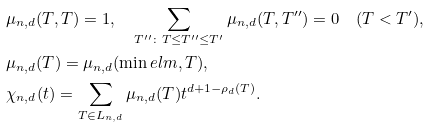Convert formula to latex. <formula><loc_0><loc_0><loc_500><loc_500>& \mu _ { n , d } ( T , T ) = 1 , \quad \sum _ { T ^ { \prime \prime } \colon T \leq T ^ { \prime \prime } \leq T ^ { \prime } } \mu _ { n , d } ( T , T ^ { \prime \prime } ) = 0 \quad ( T < T ^ { \prime } ) , \\ & \mu _ { n , d } ( T ) = \mu _ { n , d } ( \min e l m , T ) , \\ & \chi _ { n , d } ( t ) = \sum _ { T \in L _ { n , d } } \mu _ { n , d } ( T ) t ^ { d + 1 - \rho _ { d } ( T ) } .</formula> 